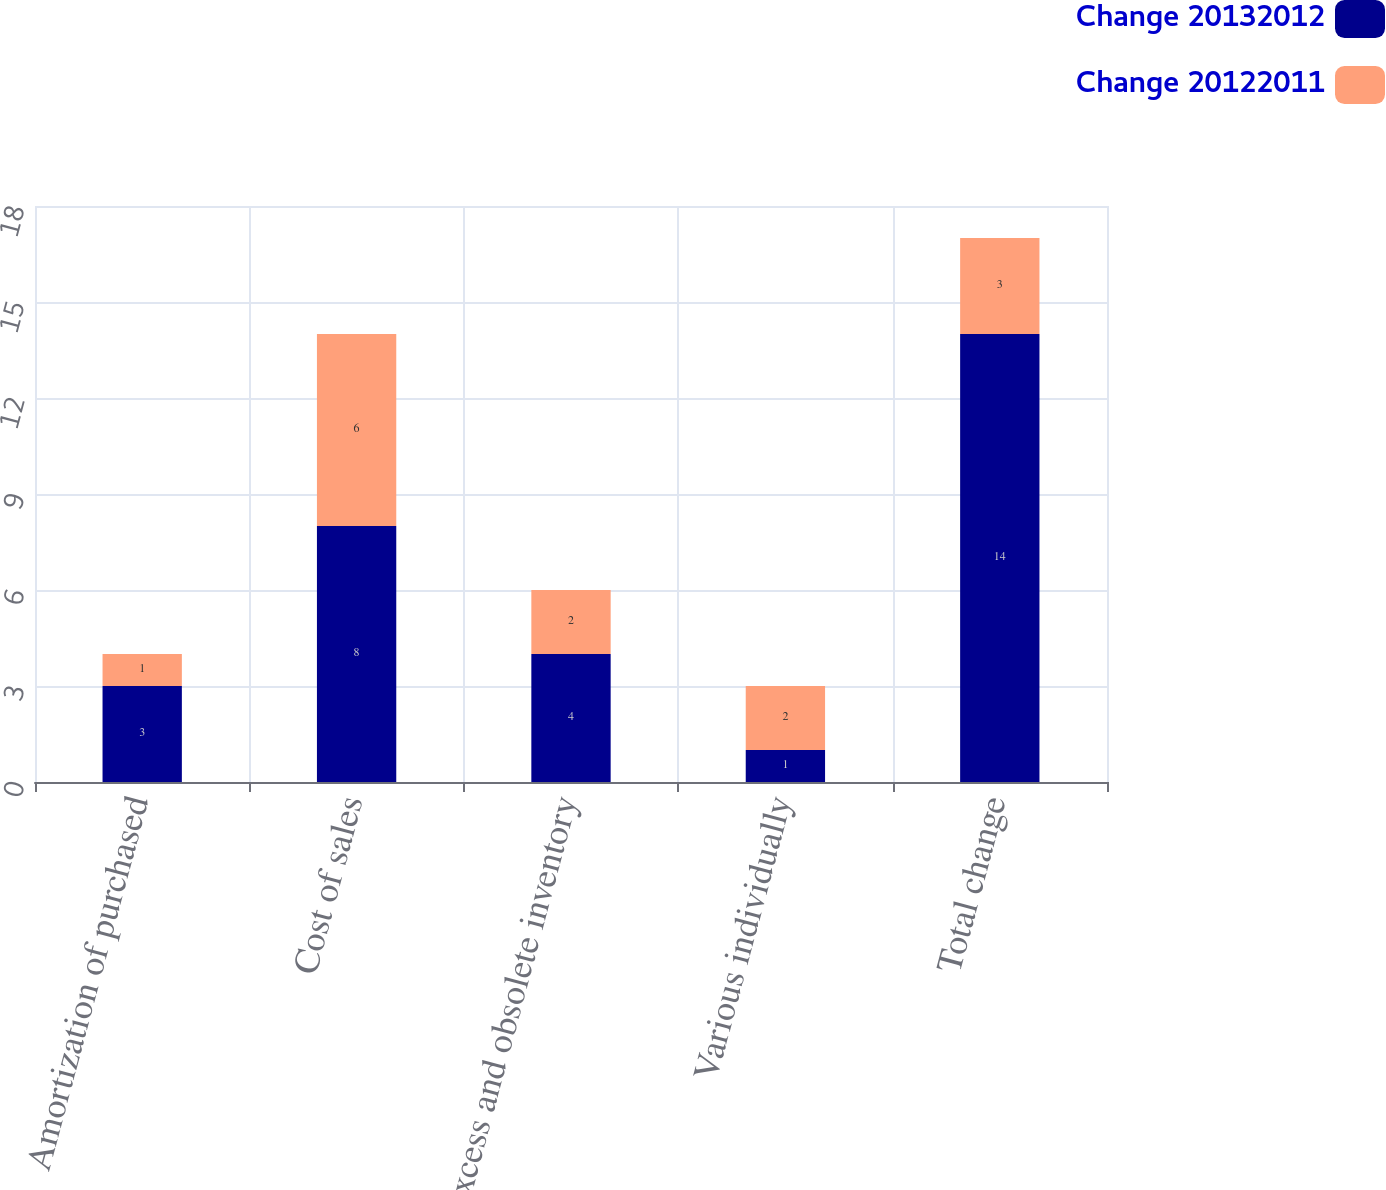<chart> <loc_0><loc_0><loc_500><loc_500><stacked_bar_chart><ecel><fcel>Amortization of purchased<fcel>Cost of sales<fcel>Excess and obsolete inventory<fcel>Various individually<fcel>Total change<nl><fcel>Change 20132012<fcel>3<fcel>8<fcel>4<fcel>1<fcel>14<nl><fcel>Change 20122011<fcel>1<fcel>6<fcel>2<fcel>2<fcel>3<nl></chart> 